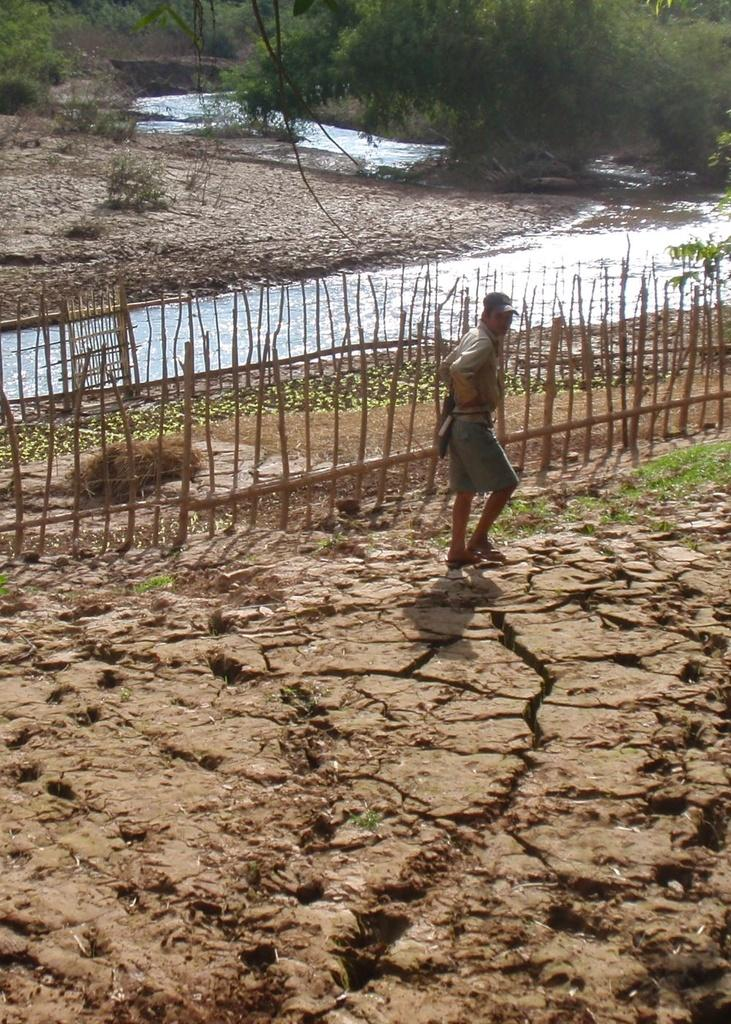What can be seen in the foreground of the picture? There is land in the foreground of the picture. What elements are present in the center of the picture? In the center of the picture, there is land, fencing, a water body, and a person. What type of vegetation is visible in the background of the picture? There are trees in the background of the picture. What other types of land can be seen in the background of the picture? There is land visible in the background of the picture. What natural feature is present in both the center and the background of the picture? There is a water body in the background of the picture. What type of advertisement can be seen on the water body in the image? There is no advertisement present on the water body in the image. What type of knife is the person using to cut the trees in the background? There is no knife or tree-cutting activity depicted in the image. 